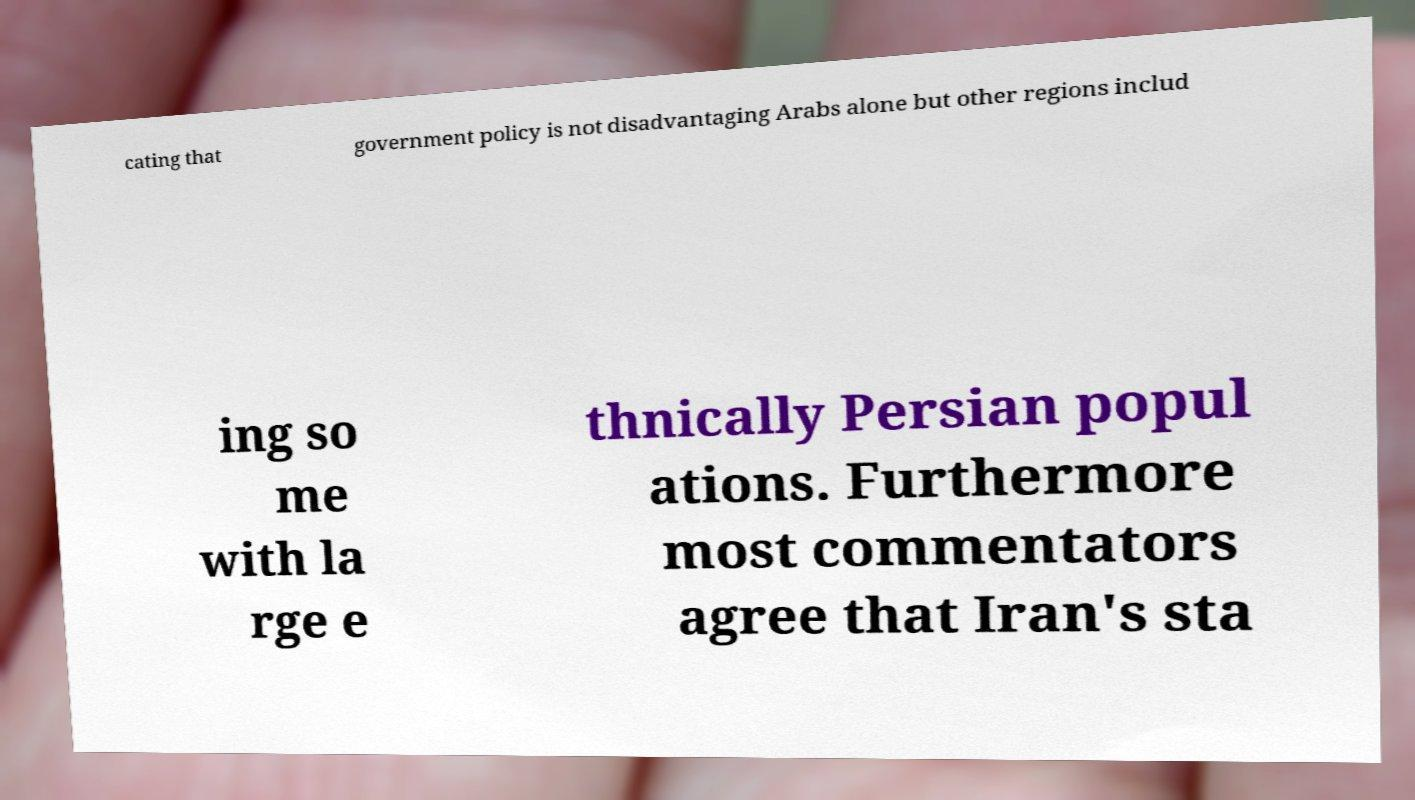I need the written content from this picture converted into text. Can you do that? cating that government policy is not disadvantaging Arabs alone but other regions includ ing so me with la rge e thnically Persian popul ations. Furthermore most commentators agree that Iran's sta 